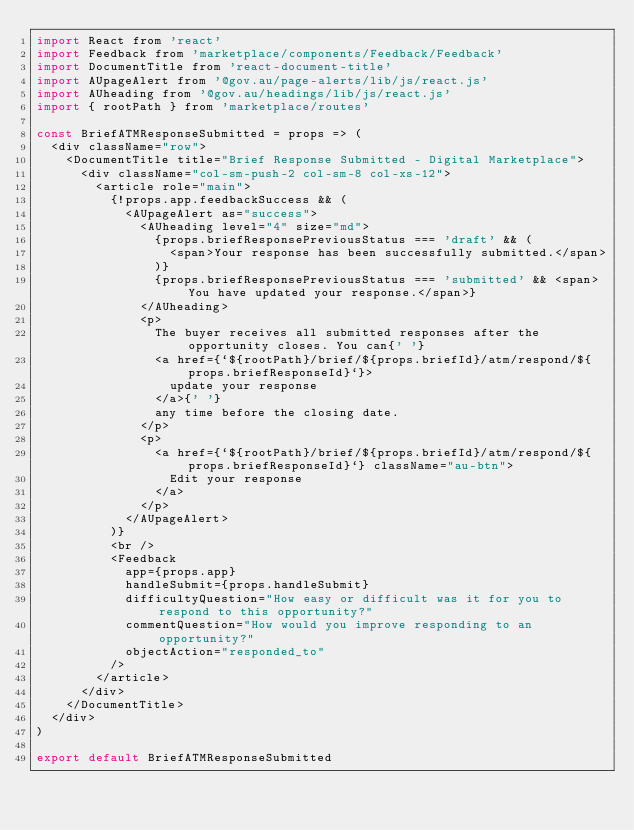<code> <loc_0><loc_0><loc_500><loc_500><_JavaScript_>import React from 'react'
import Feedback from 'marketplace/components/Feedback/Feedback'
import DocumentTitle from 'react-document-title'
import AUpageAlert from '@gov.au/page-alerts/lib/js/react.js'
import AUheading from '@gov.au/headings/lib/js/react.js'
import { rootPath } from 'marketplace/routes'

const BriefATMResponseSubmitted = props => (
  <div className="row">
    <DocumentTitle title="Brief Response Submitted - Digital Marketplace">
      <div className="col-sm-push-2 col-sm-8 col-xs-12">
        <article role="main">
          {!props.app.feedbackSuccess && (
            <AUpageAlert as="success">
              <AUheading level="4" size="md">
                {props.briefResponsePreviousStatus === 'draft' && (
                  <span>Your response has been successfully submitted.</span>
                )}
                {props.briefResponsePreviousStatus === 'submitted' && <span>You have updated your response.</span>}
              </AUheading>
              <p>
                The buyer receives all submitted responses after the opportunity closes. You can{' '}
                <a href={`${rootPath}/brief/${props.briefId}/atm/respond/${props.briefResponseId}`}>
                  update your response
                </a>{' '}
                any time before the closing date.
              </p>
              <p>
                <a href={`${rootPath}/brief/${props.briefId}/atm/respond/${props.briefResponseId}`} className="au-btn">
                  Edit your response
                </a>
              </p>
            </AUpageAlert>
          )}
          <br />
          <Feedback
            app={props.app}
            handleSubmit={props.handleSubmit}
            difficultyQuestion="How easy or difficult was it for you to respond to this opportunity?"
            commentQuestion="How would you improve responding to an opportunity?"
            objectAction="responded_to"
          />
        </article>
      </div>
    </DocumentTitle>
  </div>
)

export default BriefATMResponseSubmitted
</code> 